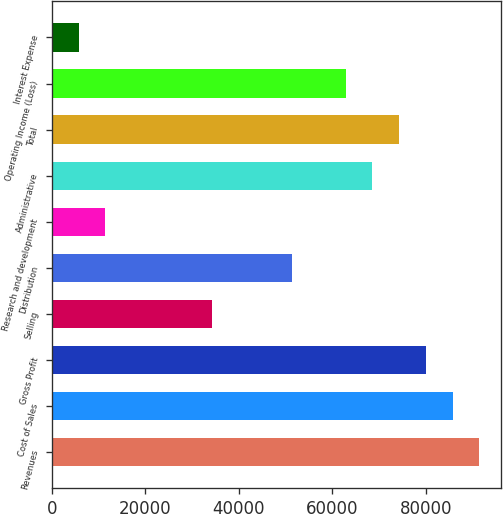<chart> <loc_0><loc_0><loc_500><loc_500><bar_chart><fcel>Revenues<fcel>Cost of Sales<fcel>Gross Profit<fcel>Selling<fcel>Distribution<fcel>Research and development<fcel>Administrative<fcel>Total<fcel>Operating Income (Loss)<fcel>Interest Expense<nl><fcel>91366.2<fcel>85658.6<fcel>79951.1<fcel>34290.5<fcel>51413.2<fcel>11460.2<fcel>68535.9<fcel>74243.5<fcel>62828.4<fcel>5752.67<nl></chart> 